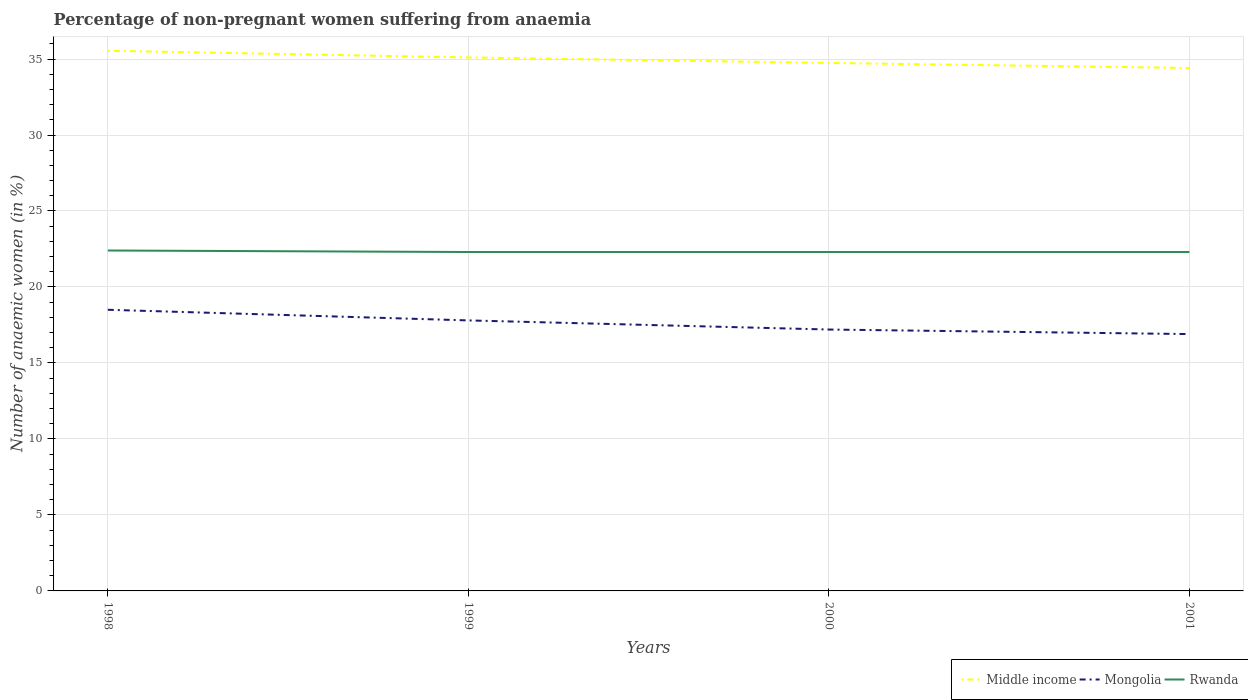How many different coloured lines are there?
Your answer should be very brief. 3. Is the number of lines equal to the number of legend labels?
Your answer should be very brief. Yes. What is the total percentage of non-pregnant women suffering from anaemia in Middle income in the graph?
Give a very brief answer. 0.33. What is the difference between the highest and the second highest percentage of non-pregnant women suffering from anaemia in Mongolia?
Ensure brevity in your answer.  1.6. What is the difference between the highest and the lowest percentage of non-pregnant women suffering from anaemia in Mongolia?
Make the answer very short. 2. Is the percentage of non-pregnant women suffering from anaemia in Mongolia strictly greater than the percentage of non-pregnant women suffering from anaemia in Middle income over the years?
Provide a succinct answer. Yes. What is the difference between two consecutive major ticks on the Y-axis?
Ensure brevity in your answer.  5. Does the graph contain grids?
Your answer should be compact. Yes. How are the legend labels stacked?
Ensure brevity in your answer.  Horizontal. What is the title of the graph?
Make the answer very short. Percentage of non-pregnant women suffering from anaemia. Does "Oman" appear as one of the legend labels in the graph?
Make the answer very short. No. What is the label or title of the X-axis?
Ensure brevity in your answer.  Years. What is the label or title of the Y-axis?
Offer a very short reply. Number of anaemic women (in %). What is the Number of anaemic women (in %) in Middle income in 1998?
Provide a succinct answer. 35.54. What is the Number of anaemic women (in %) in Rwanda in 1998?
Your response must be concise. 22.4. What is the Number of anaemic women (in %) of Middle income in 1999?
Give a very brief answer. 35.1. What is the Number of anaemic women (in %) in Mongolia in 1999?
Provide a succinct answer. 17.8. What is the Number of anaemic women (in %) of Rwanda in 1999?
Keep it short and to the point. 22.3. What is the Number of anaemic women (in %) of Middle income in 2000?
Your answer should be very brief. 34.74. What is the Number of anaemic women (in %) of Rwanda in 2000?
Offer a very short reply. 22.3. What is the Number of anaemic women (in %) in Middle income in 2001?
Provide a succinct answer. 34.41. What is the Number of anaemic women (in %) in Mongolia in 2001?
Your answer should be compact. 16.9. What is the Number of anaemic women (in %) of Rwanda in 2001?
Provide a succinct answer. 22.3. Across all years, what is the maximum Number of anaemic women (in %) in Middle income?
Provide a short and direct response. 35.54. Across all years, what is the maximum Number of anaemic women (in %) of Rwanda?
Make the answer very short. 22.4. Across all years, what is the minimum Number of anaemic women (in %) of Middle income?
Provide a short and direct response. 34.41. Across all years, what is the minimum Number of anaemic women (in %) of Mongolia?
Your answer should be very brief. 16.9. Across all years, what is the minimum Number of anaemic women (in %) in Rwanda?
Provide a succinct answer. 22.3. What is the total Number of anaemic women (in %) in Middle income in the graph?
Make the answer very short. 139.8. What is the total Number of anaemic women (in %) of Mongolia in the graph?
Offer a very short reply. 70.4. What is the total Number of anaemic women (in %) of Rwanda in the graph?
Make the answer very short. 89.3. What is the difference between the Number of anaemic women (in %) of Middle income in 1998 and that in 1999?
Ensure brevity in your answer.  0.44. What is the difference between the Number of anaemic women (in %) in Mongolia in 1998 and that in 1999?
Your answer should be compact. 0.7. What is the difference between the Number of anaemic women (in %) in Middle income in 1998 and that in 2000?
Provide a short and direct response. 0.8. What is the difference between the Number of anaemic women (in %) of Mongolia in 1998 and that in 2000?
Ensure brevity in your answer.  1.3. What is the difference between the Number of anaemic women (in %) in Rwanda in 1998 and that in 2000?
Your answer should be very brief. 0.1. What is the difference between the Number of anaemic women (in %) in Middle income in 1998 and that in 2001?
Your response must be concise. 1.13. What is the difference between the Number of anaemic women (in %) in Rwanda in 1998 and that in 2001?
Offer a very short reply. 0.1. What is the difference between the Number of anaemic women (in %) in Middle income in 1999 and that in 2000?
Offer a terse response. 0.36. What is the difference between the Number of anaemic women (in %) in Mongolia in 1999 and that in 2000?
Your response must be concise. 0.6. What is the difference between the Number of anaemic women (in %) of Middle income in 1999 and that in 2001?
Make the answer very short. 0.69. What is the difference between the Number of anaemic women (in %) in Rwanda in 1999 and that in 2001?
Keep it short and to the point. 0. What is the difference between the Number of anaemic women (in %) in Middle income in 2000 and that in 2001?
Your response must be concise. 0.33. What is the difference between the Number of anaemic women (in %) in Rwanda in 2000 and that in 2001?
Your response must be concise. 0. What is the difference between the Number of anaemic women (in %) of Middle income in 1998 and the Number of anaemic women (in %) of Mongolia in 1999?
Your response must be concise. 17.74. What is the difference between the Number of anaemic women (in %) in Middle income in 1998 and the Number of anaemic women (in %) in Rwanda in 1999?
Provide a short and direct response. 13.24. What is the difference between the Number of anaemic women (in %) in Mongolia in 1998 and the Number of anaemic women (in %) in Rwanda in 1999?
Your answer should be very brief. -3.8. What is the difference between the Number of anaemic women (in %) in Middle income in 1998 and the Number of anaemic women (in %) in Mongolia in 2000?
Give a very brief answer. 18.34. What is the difference between the Number of anaemic women (in %) of Middle income in 1998 and the Number of anaemic women (in %) of Rwanda in 2000?
Your answer should be compact. 13.24. What is the difference between the Number of anaemic women (in %) in Mongolia in 1998 and the Number of anaemic women (in %) in Rwanda in 2000?
Give a very brief answer. -3.8. What is the difference between the Number of anaemic women (in %) of Middle income in 1998 and the Number of anaemic women (in %) of Mongolia in 2001?
Provide a short and direct response. 18.64. What is the difference between the Number of anaemic women (in %) of Middle income in 1998 and the Number of anaemic women (in %) of Rwanda in 2001?
Ensure brevity in your answer.  13.24. What is the difference between the Number of anaemic women (in %) of Middle income in 1999 and the Number of anaemic women (in %) of Mongolia in 2000?
Make the answer very short. 17.91. What is the difference between the Number of anaemic women (in %) in Middle income in 1999 and the Number of anaemic women (in %) in Rwanda in 2000?
Give a very brief answer. 12.8. What is the difference between the Number of anaemic women (in %) of Middle income in 1999 and the Number of anaemic women (in %) of Mongolia in 2001?
Make the answer very short. 18.2. What is the difference between the Number of anaemic women (in %) of Middle income in 1999 and the Number of anaemic women (in %) of Rwanda in 2001?
Offer a terse response. 12.8. What is the difference between the Number of anaemic women (in %) of Mongolia in 1999 and the Number of anaemic women (in %) of Rwanda in 2001?
Provide a short and direct response. -4.5. What is the difference between the Number of anaemic women (in %) in Middle income in 2000 and the Number of anaemic women (in %) in Mongolia in 2001?
Your answer should be compact. 17.84. What is the difference between the Number of anaemic women (in %) in Middle income in 2000 and the Number of anaemic women (in %) in Rwanda in 2001?
Offer a very short reply. 12.44. What is the difference between the Number of anaemic women (in %) in Mongolia in 2000 and the Number of anaemic women (in %) in Rwanda in 2001?
Your answer should be compact. -5.1. What is the average Number of anaemic women (in %) in Middle income per year?
Give a very brief answer. 34.95. What is the average Number of anaemic women (in %) of Rwanda per year?
Make the answer very short. 22.32. In the year 1998, what is the difference between the Number of anaemic women (in %) in Middle income and Number of anaemic women (in %) in Mongolia?
Your answer should be compact. 17.04. In the year 1998, what is the difference between the Number of anaemic women (in %) in Middle income and Number of anaemic women (in %) in Rwanda?
Offer a very short reply. 13.14. In the year 1999, what is the difference between the Number of anaemic women (in %) of Middle income and Number of anaemic women (in %) of Mongolia?
Provide a succinct answer. 17.3. In the year 1999, what is the difference between the Number of anaemic women (in %) in Middle income and Number of anaemic women (in %) in Rwanda?
Provide a succinct answer. 12.8. In the year 1999, what is the difference between the Number of anaemic women (in %) in Mongolia and Number of anaemic women (in %) in Rwanda?
Give a very brief answer. -4.5. In the year 2000, what is the difference between the Number of anaemic women (in %) of Middle income and Number of anaemic women (in %) of Mongolia?
Ensure brevity in your answer.  17.54. In the year 2000, what is the difference between the Number of anaemic women (in %) in Middle income and Number of anaemic women (in %) in Rwanda?
Ensure brevity in your answer.  12.44. In the year 2001, what is the difference between the Number of anaemic women (in %) in Middle income and Number of anaemic women (in %) in Mongolia?
Provide a succinct answer. 17.51. In the year 2001, what is the difference between the Number of anaemic women (in %) of Middle income and Number of anaemic women (in %) of Rwanda?
Provide a short and direct response. 12.11. What is the ratio of the Number of anaemic women (in %) in Middle income in 1998 to that in 1999?
Your response must be concise. 1.01. What is the ratio of the Number of anaemic women (in %) of Mongolia in 1998 to that in 1999?
Offer a very short reply. 1.04. What is the ratio of the Number of anaemic women (in %) in Middle income in 1998 to that in 2000?
Provide a succinct answer. 1.02. What is the ratio of the Number of anaemic women (in %) in Mongolia in 1998 to that in 2000?
Keep it short and to the point. 1.08. What is the ratio of the Number of anaemic women (in %) of Middle income in 1998 to that in 2001?
Your answer should be compact. 1.03. What is the ratio of the Number of anaemic women (in %) of Mongolia in 1998 to that in 2001?
Give a very brief answer. 1.09. What is the ratio of the Number of anaemic women (in %) in Middle income in 1999 to that in 2000?
Your answer should be compact. 1.01. What is the ratio of the Number of anaemic women (in %) in Mongolia in 1999 to that in 2000?
Your response must be concise. 1.03. What is the ratio of the Number of anaemic women (in %) of Rwanda in 1999 to that in 2000?
Make the answer very short. 1. What is the ratio of the Number of anaemic women (in %) in Middle income in 1999 to that in 2001?
Your answer should be very brief. 1.02. What is the ratio of the Number of anaemic women (in %) in Mongolia in 1999 to that in 2001?
Make the answer very short. 1.05. What is the ratio of the Number of anaemic women (in %) of Middle income in 2000 to that in 2001?
Your response must be concise. 1.01. What is the ratio of the Number of anaemic women (in %) of Mongolia in 2000 to that in 2001?
Provide a short and direct response. 1.02. What is the ratio of the Number of anaemic women (in %) in Rwanda in 2000 to that in 2001?
Make the answer very short. 1. What is the difference between the highest and the second highest Number of anaemic women (in %) of Middle income?
Make the answer very short. 0.44. What is the difference between the highest and the lowest Number of anaemic women (in %) in Middle income?
Your answer should be compact. 1.13. What is the difference between the highest and the lowest Number of anaemic women (in %) in Rwanda?
Ensure brevity in your answer.  0.1. 